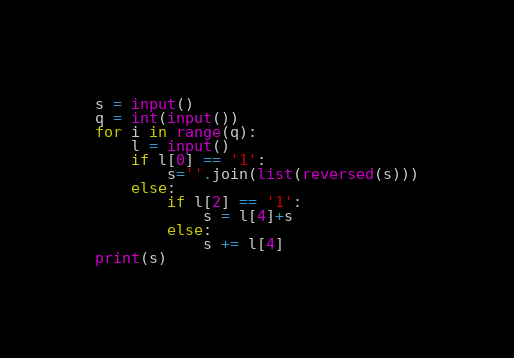<code> <loc_0><loc_0><loc_500><loc_500><_Python_>s = input()
q = int(input())
for i in range(q):
    l = input()
    if l[0] == '1':
        s=''.join(list(reversed(s)))
    else:
        if l[2] == '1':
            s = l[4]+s
        else:
            s += l[4]
print(s)</code> 